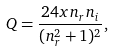Convert formula to latex. <formula><loc_0><loc_0><loc_500><loc_500>Q = \frac { 2 4 x n _ { r } n _ { i } } { ( n _ { r } ^ { 2 } + 1 ) ^ { 2 } } ,</formula> 